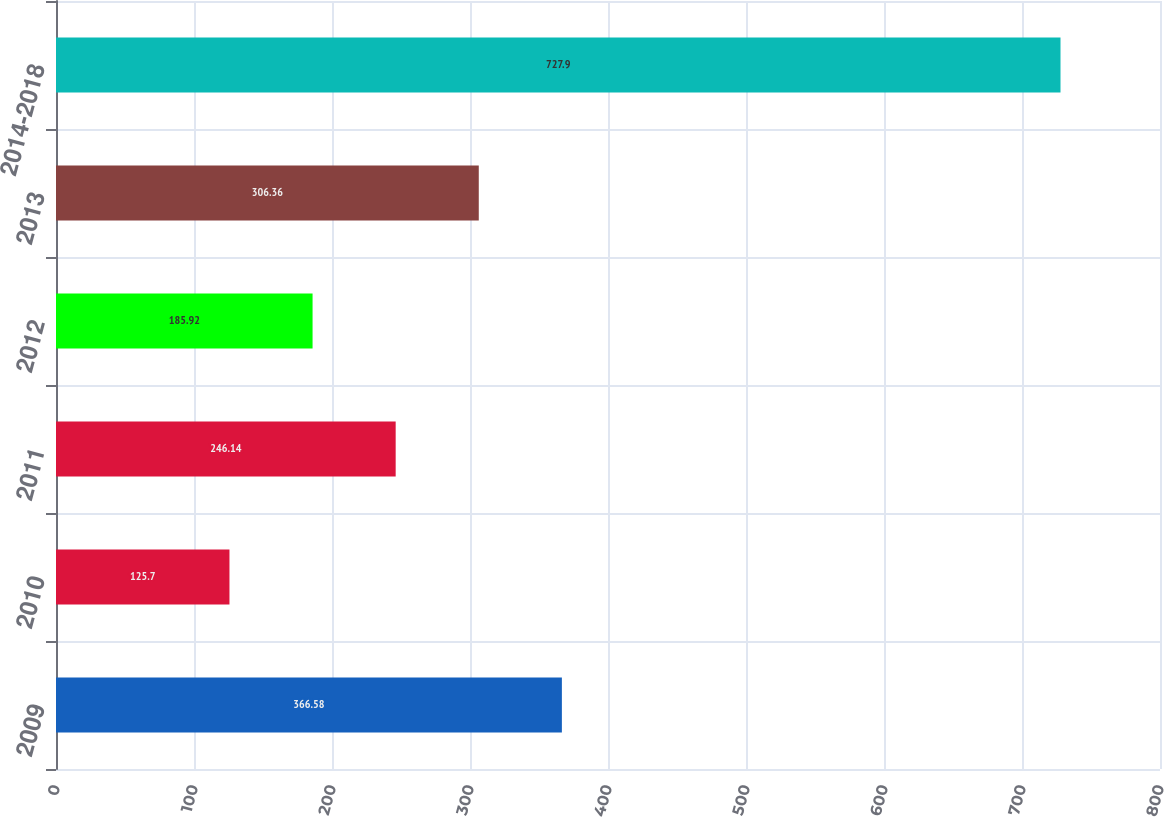<chart> <loc_0><loc_0><loc_500><loc_500><bar_chart><fcel>2009<fcel>2010<fcel>2011<fcel>2012<fcel>2013<fcel>2014-2018<nl><fcel>366.58<fcel>125.7<fcel>246.14<fcel>185.92<fcel>306.36<fcel>727.9<nl></chart> 